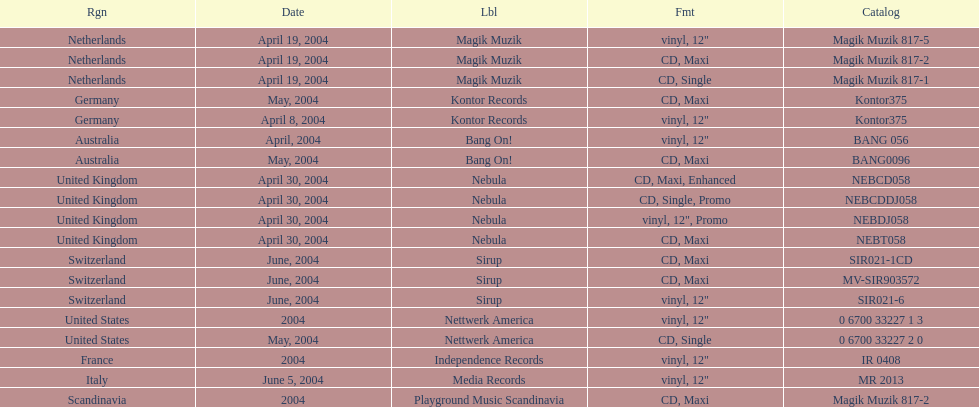What area was indicated on the syrup's label? Switzerland. 